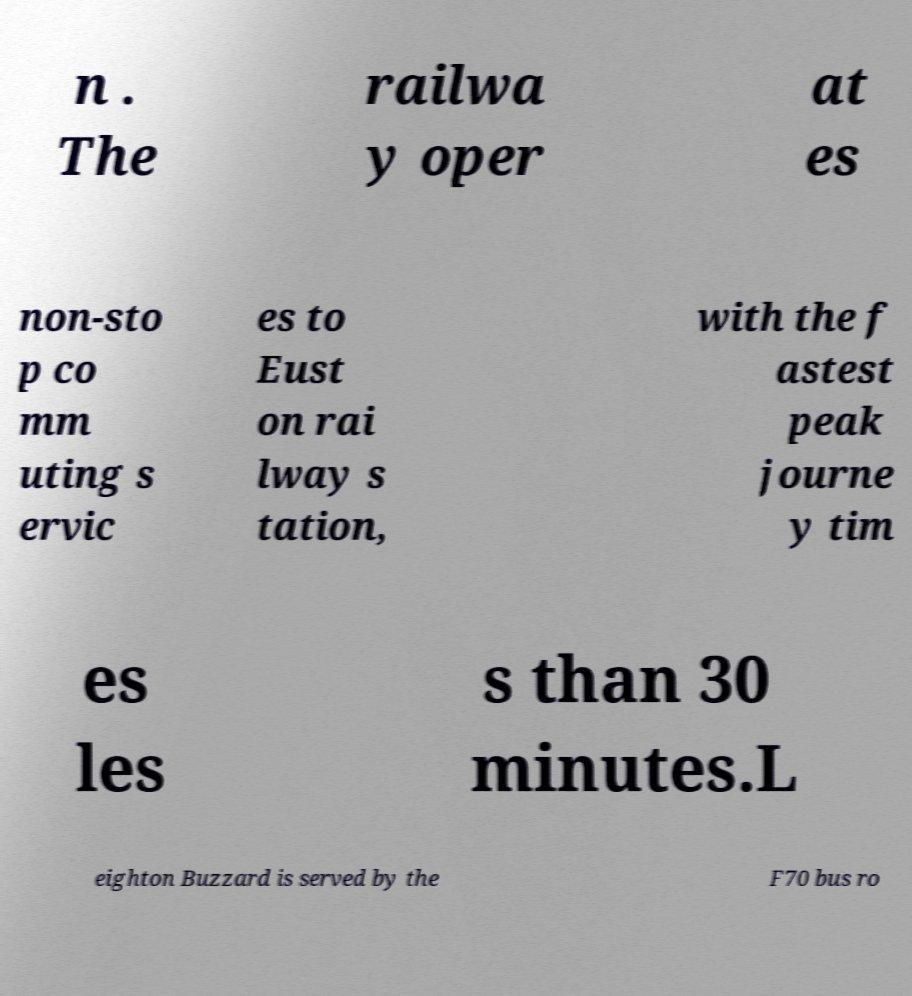For documentation purposes, I need the text within this image transcribed. Could you provide that? n . The railwa y oper at es non-sto p co mm uting s ervic es to Eust on rai lway s tation, with the f astest peak journe y tim es les s than 30 minutes.L eighton Buzzard is served by the F70 bus ro 